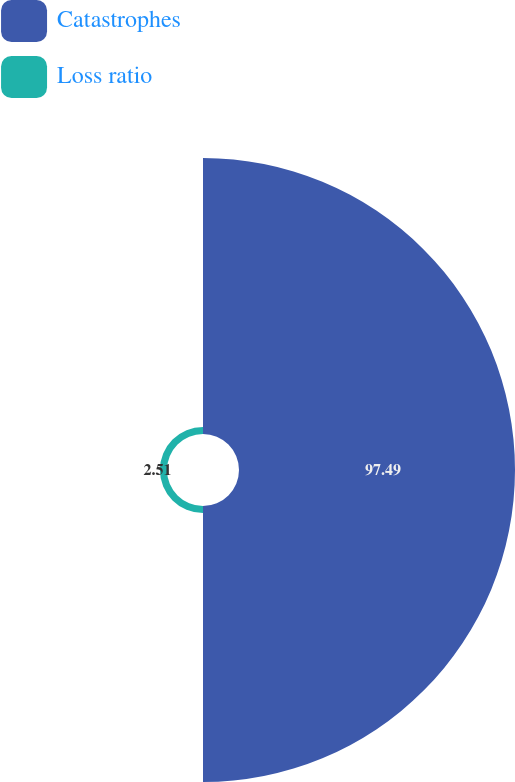<chart> <loc_0><loc_0><loc_500><loc_500><pie_chart><fcel>Catastrophes<fcel>Loss ratio<nl><fcel>97.49%<fcel>2.51%<nl></chart> 